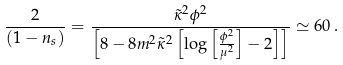<formula> <loc_0><loc_0><loc_500><loc_500>\frac { 2 } { ( 1 - n _ { s } ) } = \frac { \tilde { \kappa } ^ { 2 } \phi ^ { 2 } } { \left [ 8 - 8 m ^ { 2 } \tilde { \kappa } ^ { 2 } \left [ \log \left [ \frac { \phi ^ { 2 } } { \mu ^ { 2 } } \right ] - 2 \right ] \right ] } \simeq 6 0 \, .</formula> 